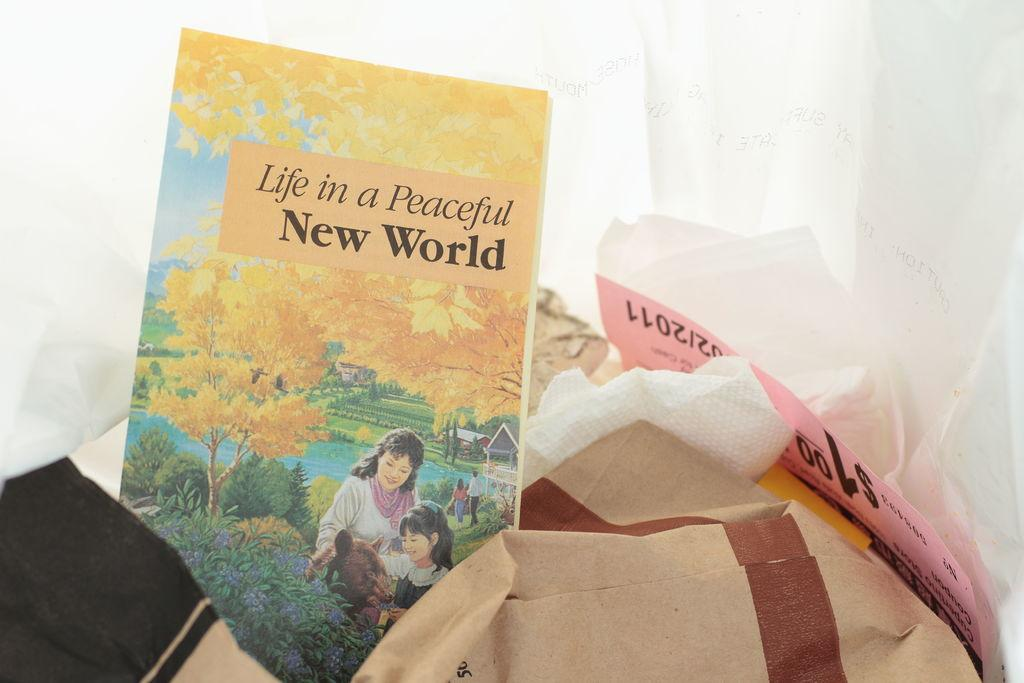<image>
Summarize the visual content of the image. In what appears to be a trash bag lies a lonely copy of the book "Life in a Peaceful New World." 